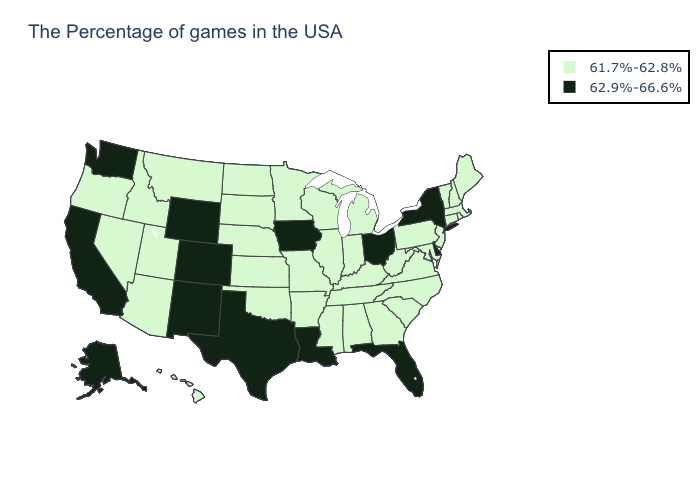How many symbols are there in the legend?
Quick response, please. 2. Name the states that have a value in the range 61.7%-62.8%?
Be succinct. Maine, Massachusetts, Rhode Island, New Hampshire, Vermont, Connecticut, New Jersey, Maryland, Pennsylvania, Virginia, North Carolina, South Carolina, West Virginia, Georgia, Michigan, Kentucky, Indiana, Alabama, Tennessee, Wisconsin, Illinois, Mississippi, Missouri, Arkansas, Minnesota, Kansas, Nebraska, Oklahoma, South Dakota, North Dakota, Utah, Montana, Arizona, Idaho, Nevada, Oregon, Hawaii. Does the map have missing data?
Keep it brief. No. Name the states that have a value in the range 62.9%-66.6%?
Give a very brief answer. New York, Delaware, Ohio, Florida, Louisiana, Iowa, Texas, Wyoming, Colorado, New Mexico, California, Washington, Alaska. Name the states that have a value in the range 62.9%-66.6%?
Concise answer only. New York, Delaware, Ohio, Florida, Louisiana, Iowa, Texas, Wyoming, Colorado, New Mexico, California, Washington, Alaska. Does Ohio have the highest value in the MidWest?
Quick response, please. Yes. What is the lowest value in the USA?
Answer briefly. 61.7%-62.8%. Which states hav the highest value in the West?
Concise answer only. Wyoming, Colorado, New Mexico, California, Washington, Alaska. Name the states that have a value in the range 61.7%-62.8%?
Answer briefly. Maine, Massachusetts, Rhode Island, New Hampshire, Vermont, Connecticut, New Jersey, Maryland, Pennsylvania, Virginia, North Carolina, South Carolina, West Virginia, Georgia, Michigan, Kentucky, Indiana, Alabama, Tennessee, Wisconsin, Illinois, Mississippi, Missouri, Arkansas, Minnesota, Kansas, Nebraska, Oklahoma, South Dakota, North Dakota, Utah, Montana, Arizona, Idaho, Nevada, Oregon, Hawaii. Does Montana have the same value as Washington?
Give a very brief answer. No. Name the states that have a value in the range 61.7%-62.8%?
Answer briefly. Maine, Massachusetts, Rhode Island, New Hampshire, Vermont, Connecticut, New Jersey, Maryland, Pennsylvania, Virginia, North Carolina, South Carolina, West Virginia, Georgia, Michigan, Kentucky, Indiana, Alabama, Tennessee, Wisconsin, Illinois, Mississippi, Missouri, Arkansas, Minnesota, Kansas, Nebraska, Oklahoma, South Dakota, North Dakota, Utah, Montana, Arizona, Idaho, Nevada, Oregon, Hawaii. Name the states that have a value in the range 61.7%-62.8%?
Keep it brief. Maine, Massachusetts, Rhode Island, New Hampshire, Vermont, Connecticut, New Jersey, Maryland, Pennsylvania, Virginia, North Carolina, South Carolina, West Virginia, Georgia, Michigan, Kentucky, Indiana, Alabama, Tennessee, Wisconsin, Illinois, Mississippi, Missouri, Arkansas, Minnesota, Kansas, Nebraska, Oklahoma, South Dakota, North Dakota, Utah, Montana, Arizona, Idaho, Nevada, Oregon, Hawaii. What is the value of Massachusetts?
Give a very brief answer. 61.7%-62.8%. Among the states that border Georgia , which have the lowest value?
Answer briefly. North Carolina, South Carolina, Alabama, Tennessee. What is the value of Hawaii?
Write a very short answer. 61.7%-62.8%. 